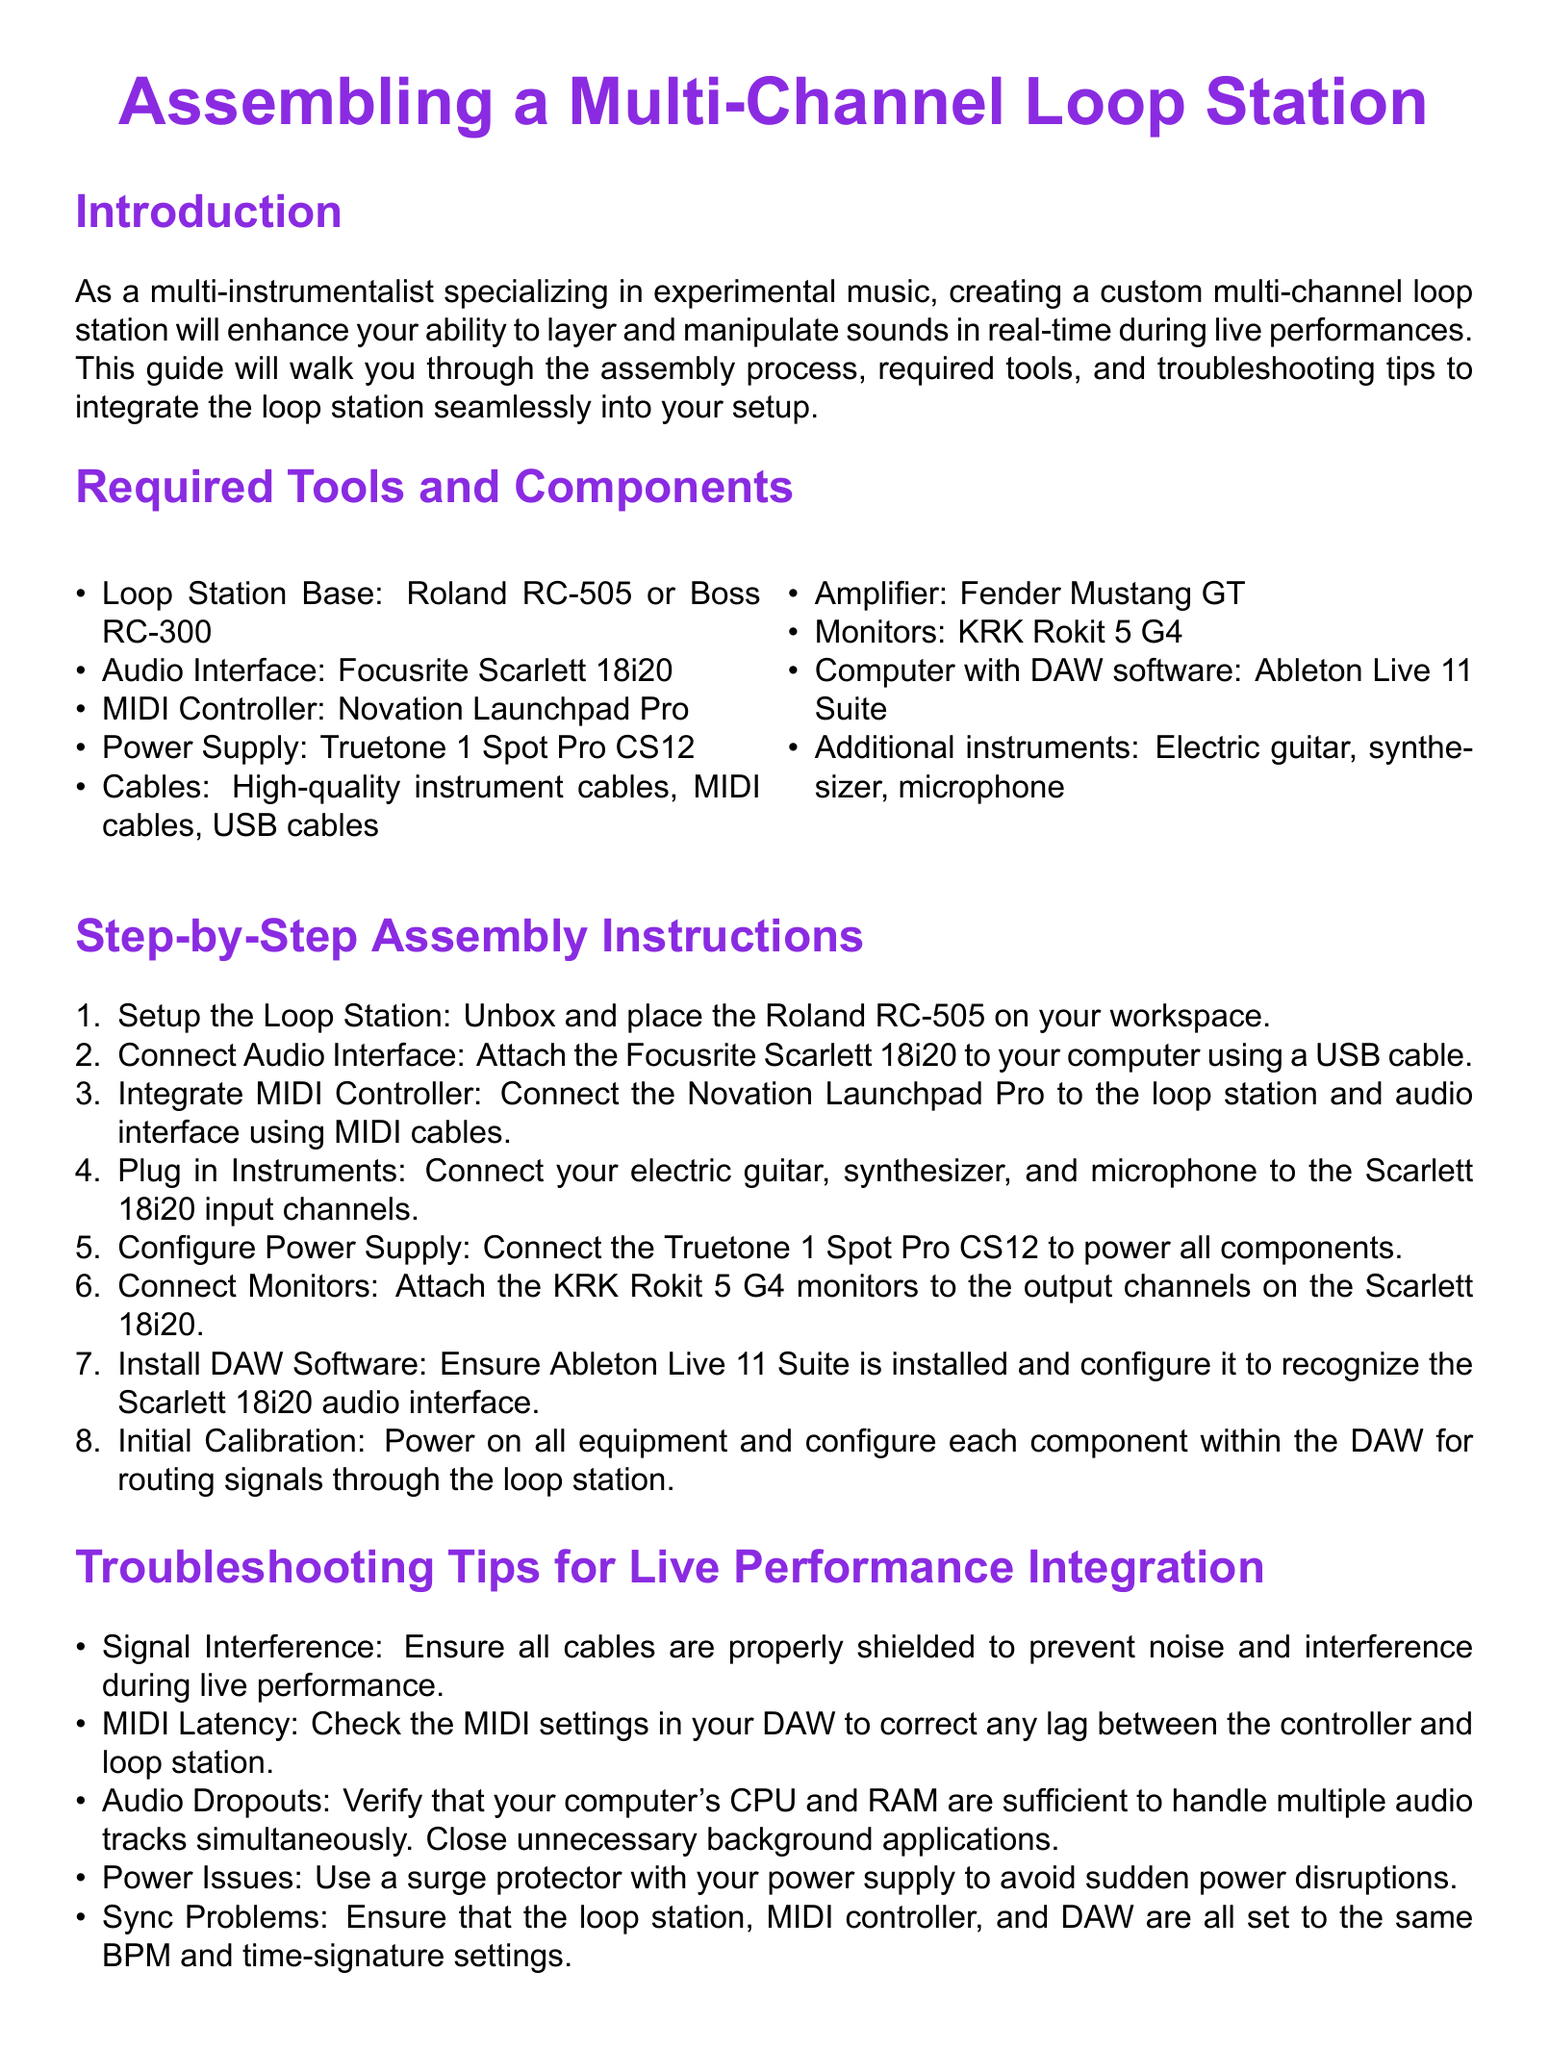What is the loop station base mentioned? The document specifies the loop station base as either the Roland RC-505 or Boss RC-300.
Answer: Roland RC-505 or Boss RC-300 What is one of the monitors recommended? The document lists KRK Rokit 5 G4 as one of the required monitors for the setup.
Answer: KRK Rokit 5 G4 How many steps are there in the assembly instructions? The assembly instructions section contains a total of eight steps.
Answer: Eight What should be connected to the audio interface? The document states that the electric guitar, synthesizer, and microphone should be connected to the Scarlett 18i20 input channels.
Answer: Electric guitar, synthesizer, and microphone What device is suggested for audio interface? The recommended audio interface according to the document is the Focusrite Scarlett 18i20.
Answer: Focusrite Scarlett 18i20 What is a troubleshooting tip related to audio dropouts? The document advises that users verify their computer's CPU and RAM to prevent audio dropouts during live performance.
Answer: Verify CPU and RAM How can signal interference be prevented? According to the document, using properly shielded cables can help prevent noise and interference.
Answer: Properly shielded cables What software must be installed for the setup? The document mentions that Ableton Live 11 Suite should be installed to configure the setup.
Answer: Ableton Live 11 Suite What power supply is recommended? The Truetone 1 Spot Pro CS12 is specified as the recommended power supply for the setup.
Answer: Truetone 1 Spot Pro CS12 